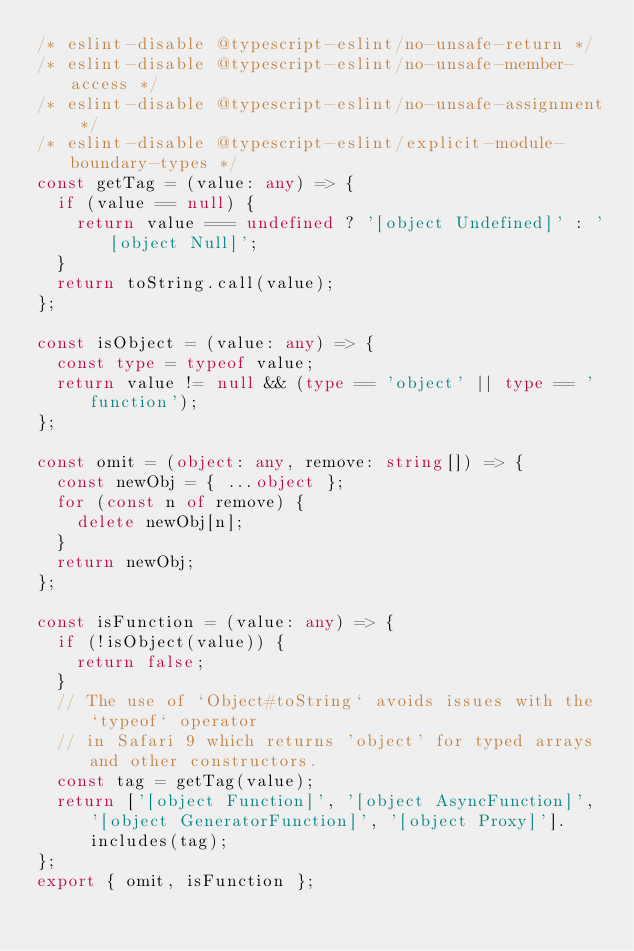Convert code to text. <code><loc_0><loc_0><loc_500><loc_500><_TypeScript_>/* eslint-disable @typescript-eslint/no-unsafe-return */
/* eslint-disable @typescript-eslint/no-unsafe-member-access */
/* eslint-disable @typescript-eslint/no-unsafe-assignment */
/* eslint-disable @typescript-eslint/explicit-module-boundary-types */
const getTag = (value: any) => {
  if (value == null) {
    return value === undefined ? '[object Undefined]' : '[object Null]';
  }
  return toString.call(value);
};

const isObject = (value: any) => {
  const type = typeof value;
  return value != null && (type == 'object' || type == 'function');
};

const omit = (object: any, remove: string[]) => {
  const newObj = { ...object };
  for (const n of remove) {
    delete newObj[n];
  }
  return newObj;
};

const isFunction = (value: any) => {
  if (!isObject(value)) {
    return false;
  }
  // The use of `Object#toString` avoids issues with the `typeof` operator
  // in Safari 9 which returns 'object' for typed arrays and other constructors.
  const tag = getTag(value);
  return ['[object Function]', '[object AsyncFunction]', '[object GeneratorFunction]', '[object Proxy]'].includes(tag);
};
export { omit, isFunction };
</code> 